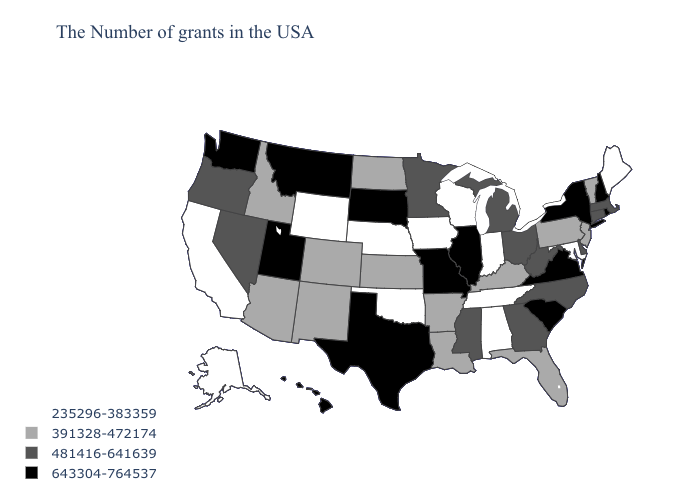What is the value of Alaska?
Quick response, please. 235296-383359. Among the states that border Alabama , does Georgia have the lowest value?
Concise answer only. No. Name the states that have a value in the range 643304-764537?
Give a very brief answer. Rhode Island, New Hampshire, New York, Virginia, South Carolina, Illinois, Missouri, Texas, South Dakota, Utah, Montana, Washington, Hawaii. What is the value of Maine?
Concise answer only. 235296-383359. Does Texas have a higher value than Vermont?
Quick response, please. Yes. Among the states that border Minnesota , does Iowa have the highest value?
Quick response, please. No. What is the value of Missouri?
Answer briefly. 643304-764537. What is the highest value in the South ?
Keep it brief. 643304-764537. Which states have the lowest value in the USA?
Quick response, please. Maine, Maryland, Indiana, Alabama, Tennessee, Wisconsin, Iowa, Nebraska, Oklahoma, Wyoming, California, Alaska. Does Wisconsin have the highest value in the MidWest?
Short answer required. No. What is the value of South Dakota?
Quick response, please. 643304-764537. Does Nevada have the highest value in the West?
Concise answer only. No. Does the map have missing data?
Give a very brief answer. No. Does New York have the highest value in the Northeast?
Give a very brief answer. Yes. Name the states that have a value in the range 391328-472174?
Quick response, please. Vermont, New Jersey, Pennsylvania, Florida, Kentucky, Louisiana, Arkansas, Kansas, North Dakota, Colorado, New Mexico, Arizona, Idaho. 